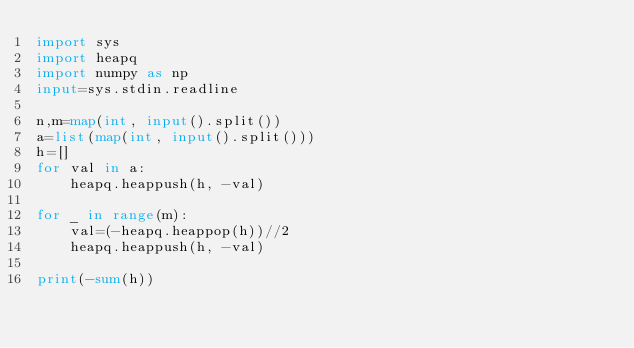<code> <loc_0><loc_0><loc_500><loc_500><_Python_>import sys
import heapq
import numpy as np
input=sys.stdin.readline

n,m=map(int, input().split())
a=list(map(int, input().split()))
h=[]
for val in a:
    heapq.heappush(h, -val)

for _ in range(m):
    val=(-heapq.heappop(h))//2
    heapq.heappush(h, -val)

print(-sum(h))
</code> 